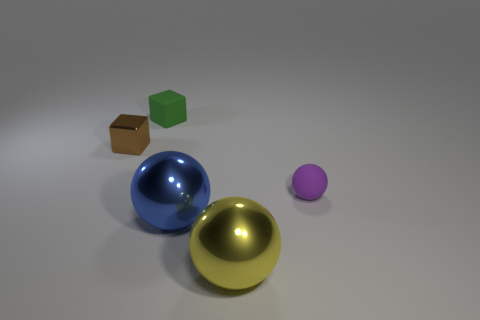Add 5 tiny red balls. How many objects exist? 10 Subtract all big metal spheres. How many spheres are left? 1 Subtract all yellow spheres. How many spheres are left? 2 Subtract all spheres. How many objects are left? 2 Subtract 1 cubes. How many cubes are left? 1 Subtract all brown cylinders. How many blue spheres are left? 1 Subtract all tiny brown metallic things. Subtract all brown cubes. How many objects are left? 3 Add 5 small brown things. How many small brown things are left? 6 Add 4 large cyan metal cylinders. How many large cyan metal cylinders exist? 4 Subtract 1 purple spheres. How many objects are left? 4 